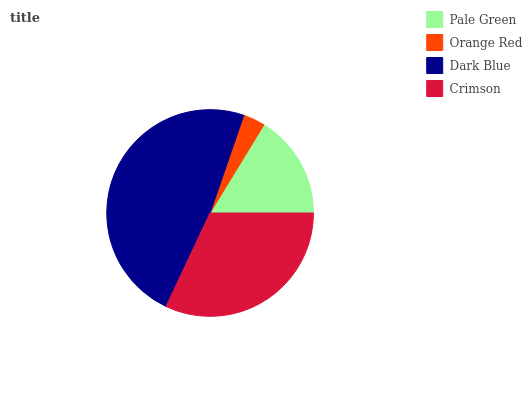Is Orange Red the minimum?
Answer yes or no. Yes. Is Dark Blue the maximum?
Answer yes or no. Yes. Is Dark Blue the minimum?
Answer yes or no. No. Is Orange Red the maximum?
Answer yes or no. No. Is Dark Blue greater than Orange Red?
Answer yes or no. Yes. Is Orange Red less than Dark Blue?
Answer yes or no. Yes. Is Orange Red greater than Dark Blue?
Answer yes or no. No. Is Dark Blue less than Orange Red?
Answer yes or no. No. Is Crimson the high median?
Answer yes or no. Yes. Is Pale Green the low median?
Answer yes or no. Yes. Is Dark Blue the high median?
Answer yes or no. No. Is Crimson the low median?
Answer yes or no. No. 